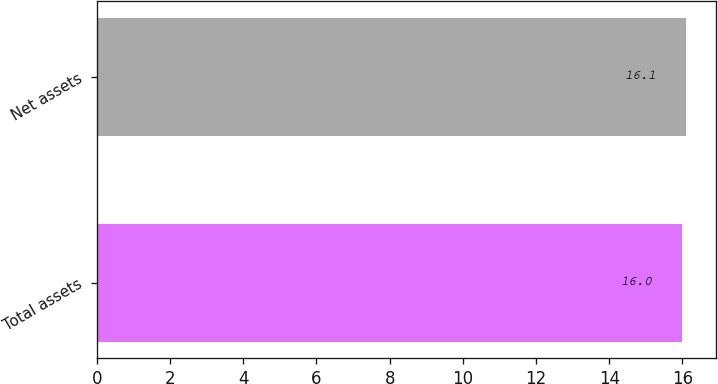Convert chart to OTSL. <chart><loc_0><loc_0><loc_500><loc_500><bar_chart><fcel>Total assets<fcel>Net assets<nl><fcel>16<fcel>16.1<nl></chart> 